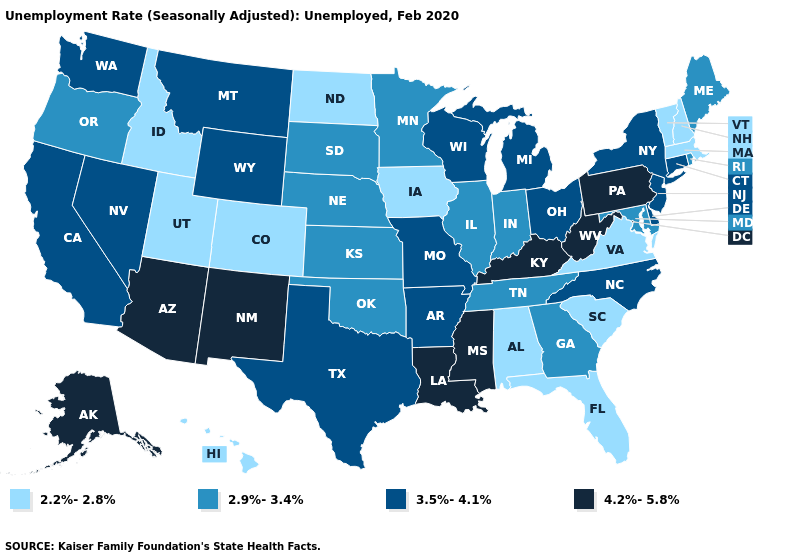Does the first symbol in the legend represent the smallest category?
Be succinct. Yes. Does Pennsylvania have the highest value in the USA?
Short answer required. Yes. Name the states that have a value in the range 2.2%-2.8%?
Short answer required. Alabama, Colorado, Florida, Hawaii, Idaho, Iowa, Massachusetts, New Hampshire, North Dakota, South Carolina, Utah, Vermont, Virginia. What is the lowest value in the USA?
Keep it brief. 2.2%-2.8%. Name the states that have a value in the range 2.2%-2.8%?
Write a very short answer. Alabama, Colorado, Florida, Hawaii, Idaho, Iowa, Massachusetts, New Hampshire, North Dakota, South Carolina, Utah, Vermont, Virginia. Name the states that have a value in the range 2.9%-3.4%?
Give a very brief answer. Georgia, Illinois, Indiana, Kansas, Maine, Maryland, Minnesota, Nebraska, Oklahoma, Oregon, Rhode Island, South Dakota, Tennessee. Name the states that have a value in the range 2.9%-3.4%?
Answer briefly. Georgia, Illinois, Indiana, Kansas, Maine, Maryland, Minnesota, Nebraska, Oklahoma, Oregon, Rhode Island, South Dakota, Tennessee. How many symbols are there in the legend?
Quick response, please. 4. Name the states that have a value in the range 2.2%-2.8%?
Keep it brief. Alabama, Colorado, Florida, Hawaii, Idaho, Iowa, Massachusetts, New Hampshire, North Dakota, South Carolina, Utah, Vermont, Virginia. What is the value of Oklahoma?
Give a very brief answer. 2.9%-3.4%. Is the legend a continuous bar?
Give a very brief answer. No. Which states have the lowest value in the West?
Concise answer only. Colorado, Hawaii, Idaho, Utah. What is the value of Idaho?
Answer briefly. 2.2%-2.8%. What is the highest value in states that border Mississippi?
Be succinct. 4.2%-5.8%. Name the states that have a value in the range 2.9%-3.4%?
Concise answer only. Georgia, Illinois, Indiana, Kansas, Maine, Maryland, Minnesota, Nebraska, Oklahoma, Oregon, Rhode Island, South Dakota, Tennessee. 